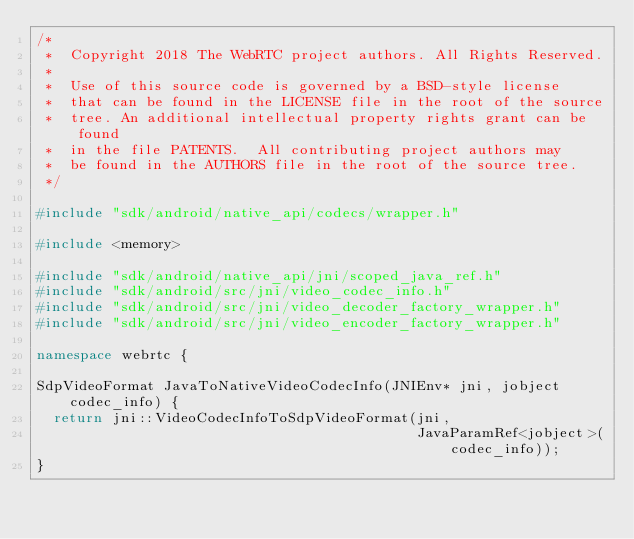<code> <loc_0><loc_0><loc_500><loc_500><_C++_>/*
 *  Copyright 2018 The WebRTC project authors. All Rights Reserved.
 *
 *  Use of this source code is governed by a BSD-style license
 *  that can be found in the LICENSE file in the root of the source
 *  tree. An additional intellectual property rights grant can be found
 *  in the file PATENTS.  All contributing project authors may
 *  be found in the AUTHORS file in the root of the source tree.
 */

#include "sdk/android/native_api/codecs/wrapper.h"

#include <memory>

#include "sdk/android/native_api/jni/scoped_java_ref.h"
#include "sdk/android/src/jni/video_codec_info.h"
#include "sdk/android/src/jni/video_decoder_factory_wrapper.h"
#include "sdk/android/src/jni/video_encoder_factory_wrapper.h"

namespace webrtc {

SdpVideoFormat JavaToNativeVideoCodecInfo(JNIEnv* jni, jobject codec_info) {
  return jni::VideoCodecInfoToSdpVideoFormat(jni,
                                             JavaParamRef<jobject>(codec_info));
}
</code> 